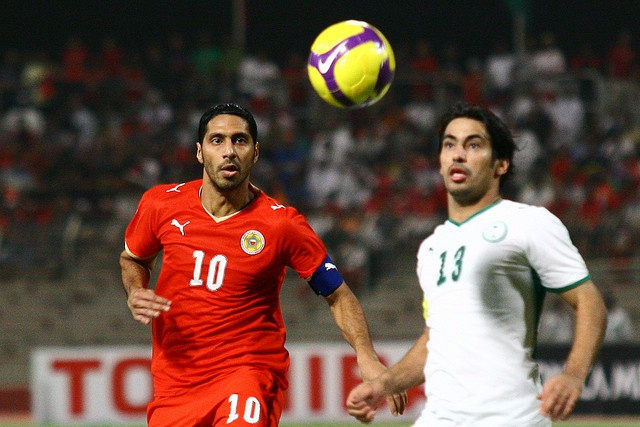Describe the objects in this image and their specific colors. I can see people in black, red, brown, and maroon tones, people in black, white, gray, and darkgray tones, sports ball in black, yellow, and olive tones, and people in black and gray tones in this image. 